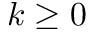<formula> <loc_0><loc_0><loc_500><loc_500>k \geq 0</formula> 